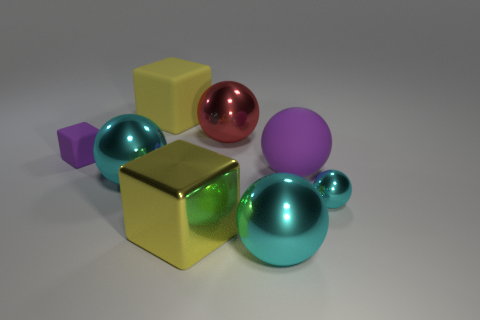What is the shape of the matte object that is to the left of the large metal ball left of the yellow shiny cube that is in front of the small matte block?
Make the answer very short. Cube. What is the shape of the tiny object that is to the left of the red metal sphere?
Give a very brief answer. Cube. Are the small cube and the big block that is in front of the large red shiny thing made of the same material?
Provide a short and direct response. No. How many other things are there of the same shape as the yellow metal object?
Your answer should be compact. 2. Do the small metal thing and the large object in front of the big yellow shiny block have the same color?
Keep it short and to the point. Yes. Are there any other things that have the same material as the red ball?
Your answer should be compact. Yes. The big cyan thing that is in front of the big yellow block in front of the big red metallic ball is what shape?
Offer a terse response. Sphere. The other block that is the same color as the large matte cube is what size?
Provide a short and direct response. Large. There is a shiny thing that is behind the purple block; is it the same shape as the tiny metallic object?
Offer a very short reply. Yes. Are there more large red balls in front of the big metallic block than large cyan shiny things that are to the left of the purple sphere?
Provide a succinct answer. No. 